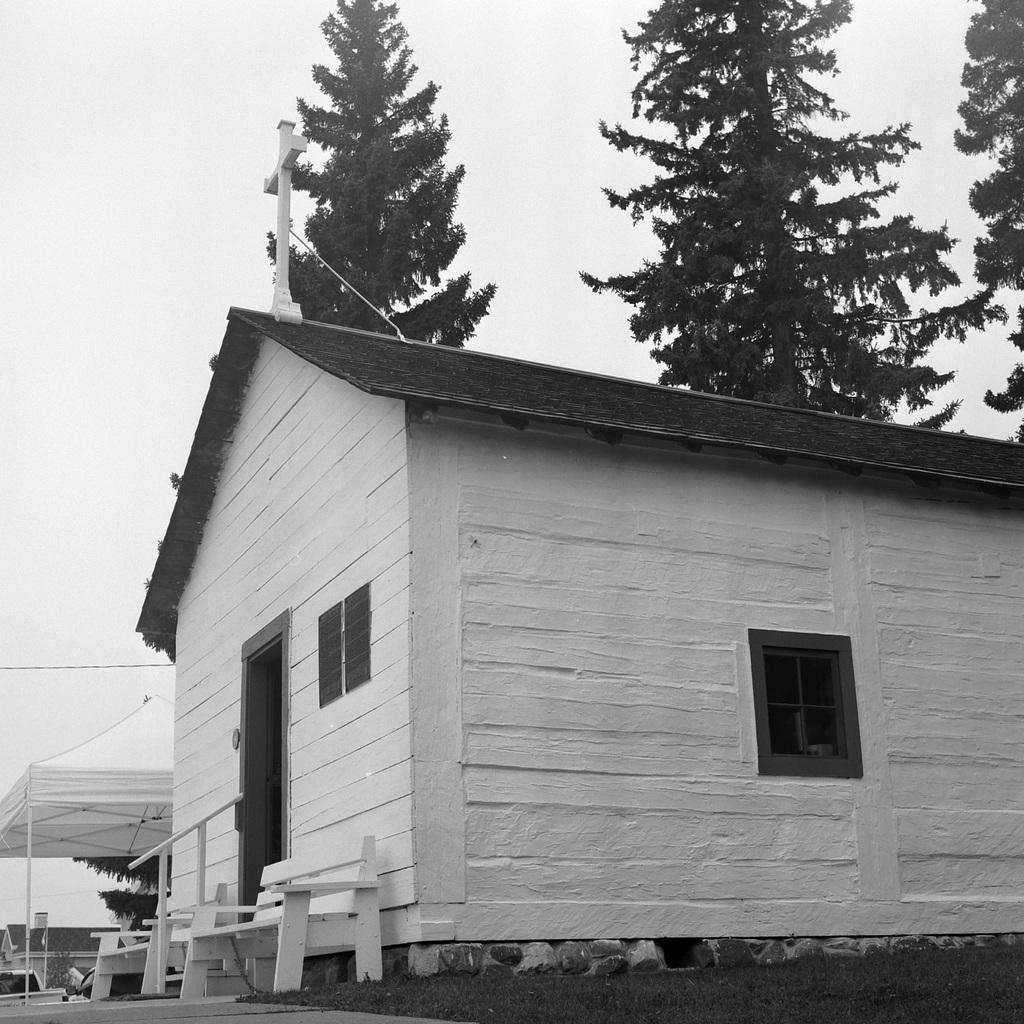What is the color scheme of the image? The image is black and white. What is the main subject in the center of the image? There is a house in the center of the image. What can be seen on the left side of the image? There is a tent and benches on the left side of the image. What is visible in the background of the image? There are trees and the sky in the background of the image. What is the opinion of the police in the image? There is no reference to the police or any opinions in the image. 